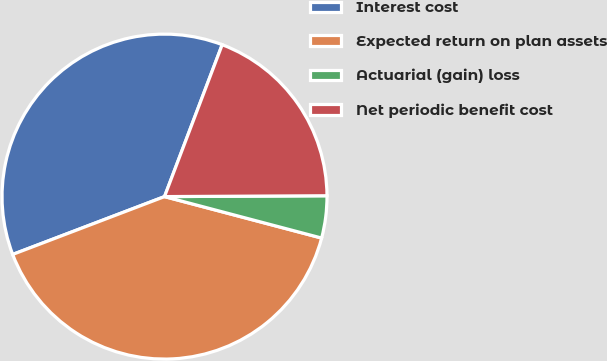<chart> <loc_0><loc_0><loc_500><loc_500><pie_chart><fcel>Interest cost<fcel>Expected return on plan assets<fcel>Actuarial (gain) loss<fcel>Net periodic benefit cost<nl><fcel>36.57%<fcel>40.1%<fcel>4.19%<fcel>19.14%<nl></chart> 